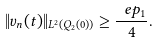Convert formula to latex. <formula><loc_0><loc_0><loc_500><loc_500>\| v _ { n } ( t ) \| _ { L ^ { 2 } ( Q _ { 2 } ( 0 ) ) } \geq \frac { \ e p _ { 1 } } { 4 } .</formula> 